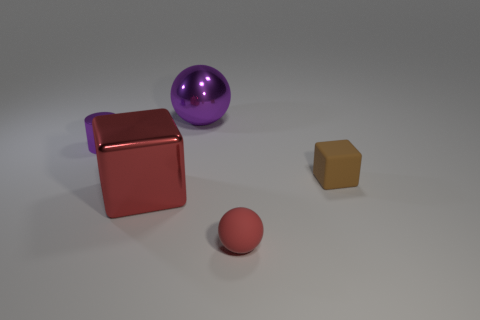Subtract all purple spheres. How many spheres are left? 1 Add 4 large green metallic cylinders. How many objects exist? 9 Subtract all cylinders. How many objects are left? 4 Subtract 0 yellow spheres. How many objects are left? 5 Subtract all gray cylinders. Subtract all red objects. How many objects are left? 3 Add 3 small purple shiny cylinders. How many small purple shiny cylinders are left? 4 Add 1 rubber objects. How many rubber objects exist? 3 